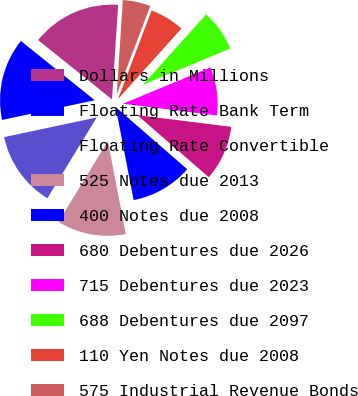Convert chart. <chart><loc_0><loc_0><loc_500><loc_500><pie_chart><fcel>Dollars in Millions<fcel>Floating Rate Bank Term<fcel>Floating Rate Convertible<fcel>525 Notes due 2013<fcel>400 Notes due 2008<fcel>680 Debentures due 2026<fcel>715 Debentures due 2023<fcel>688 Debentures due 2097<fcel>110 Yen Notes due 2008<fcel>575 Industrial Revenue Bonds<nl><fcel>15.27%<fcel>14.1%<fcel>12.93%<fcel>11.76%<fcel>10.59%<fcel>9.41%<fcel>8.24%<fcel>7.07%<fcel>5.9%<fcel>4.73%<nl></chart> 